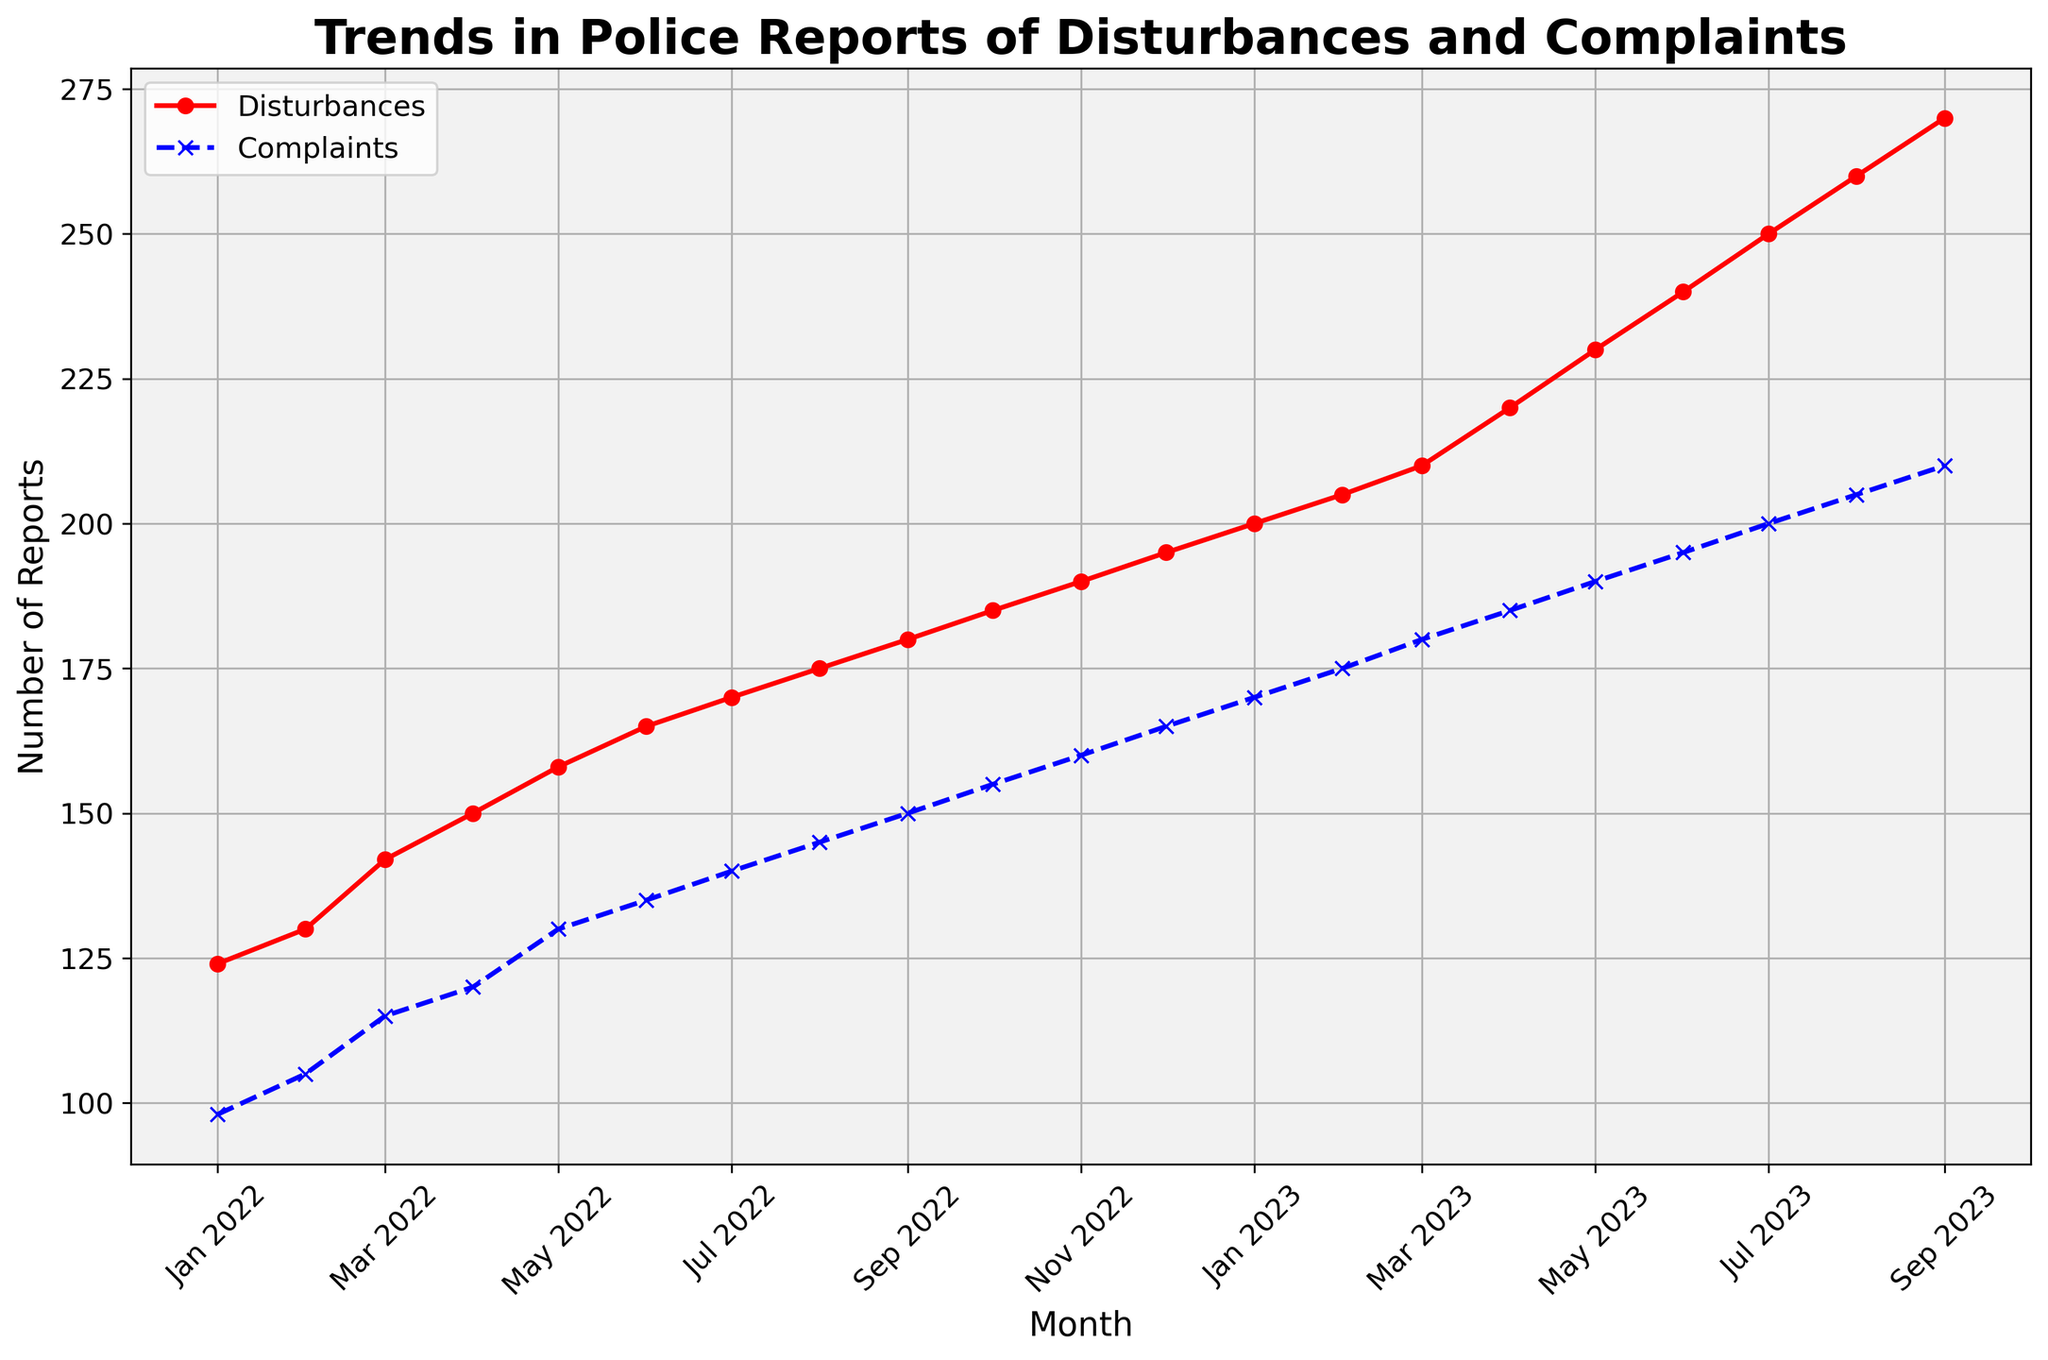What is the trend in police reports of disturbances from January 2022 to September 2023? By observing the red line representing disturbances, we see a steady increase each month. The disturbances rise from 124 in January 2022 to 270 in September 2023.
Answer: Steady increase By how much did the number of complaints increase from January 2022 to September 2023? The complaints in January 2022 were 98, and by September 2023, they were 210. The increase is calculated as 210 - 98.
Answer: 112 When did disturbances first reach or exceed 200 reports? Observing the red line and referencing the month labels, disturbances reached 200 reports in January 2023.
Answer: January 2023 Which month had the largest difference between disturbances and complaints? By visually comparing the gaps between the red and blue lines for each month, the month with the largest difference appears to be January 2022, with disturbances at 124 and complaints at 98, a difference of 26.
Answer: January 2022 What can be inferred about the relationship between disturbances and complaints over time? Both lines show a steady increase each month, indicating that disturbances and complaints are correlated and rise together over time.
Answer: Correlated and rising together How did the number of complaints change between December 2022 and January 2023? The complaints in December 2022 were 165 and in January 2023 increased to 170, an increase of 5.
Answer: Increased by 5 Which color represents the disturbances in the line chart? Disturbances are represented by the red line marked with circles.
Answer: Red What is the average number of disturbances reported between January 2023 and September 2023? The disturbances for these months are 200, 205, 210, 220, 230, 240, 250, 260, and 270. Sum these values: 200+205+210+220+230+240+250+260+270 = 2085. There are 9 months, so the average is 2085/9.
Answer: 231.67 What is the difference in the number of disturbances reported between July 2022 and July 2023? Disturbances in July 2022 were 170, and in July 2023, they were 250. The difference is calculated as 250 - 170.
Answer: 80 During which month did complaints number first equal or exceed 150? Observing the blue line and month labels, complaints reached 150 in September 2022.
Answer: September 2022 